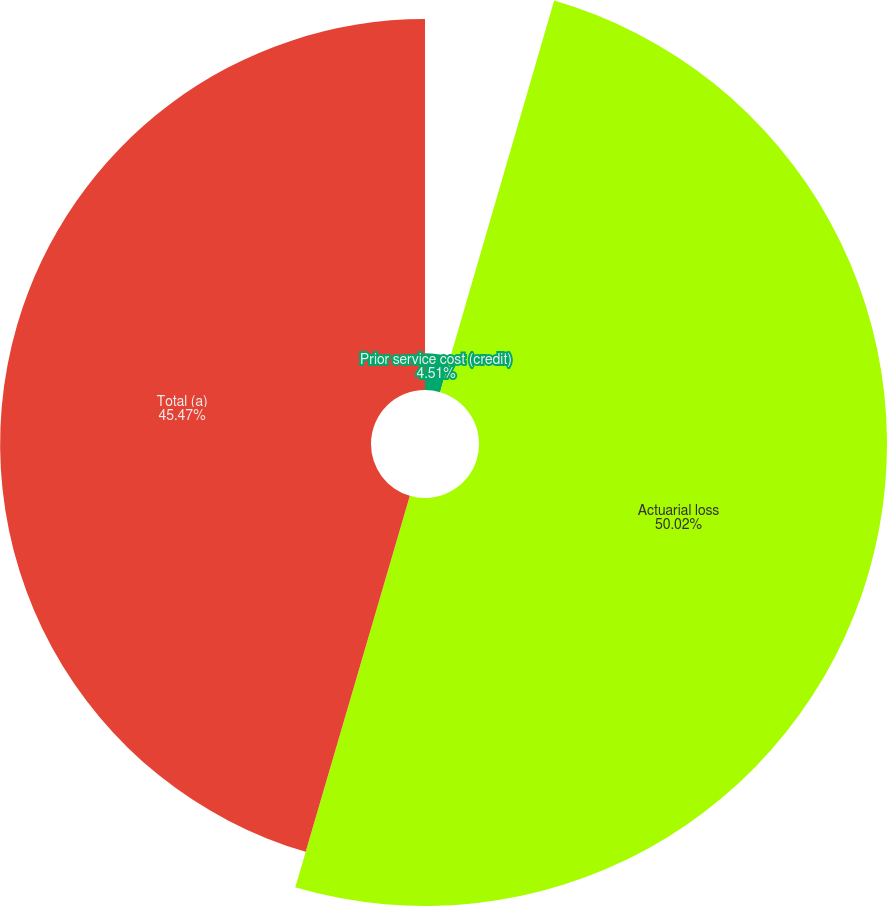Convert chart. <chart><loc_0><loc_0><loc_500><loc_500><pie_chart><fcel>Prior service cost (credit)<fcel>Actuarial loss<fcel>Total (a)<nl><fcel>4.51%<fcel>50.02%<fcel>45.47%<nl></chart> 